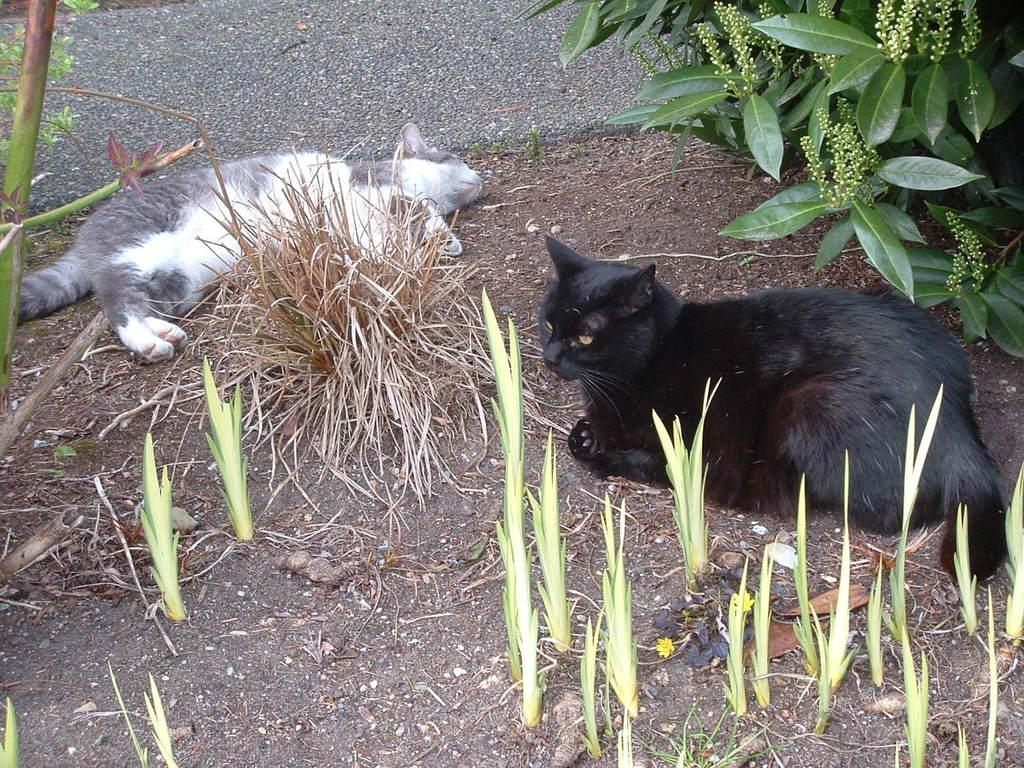What animals are in the center of the image? There are two cats in the center of the image. What else can be seen in the image besides the cats? There are plants and soil visible in the image. What is the background of the image? There are plants in the background of the image. What type of bottle is being blown by the wind in the image? There is no bottle or wind present in the image; it features two cats and plants. 